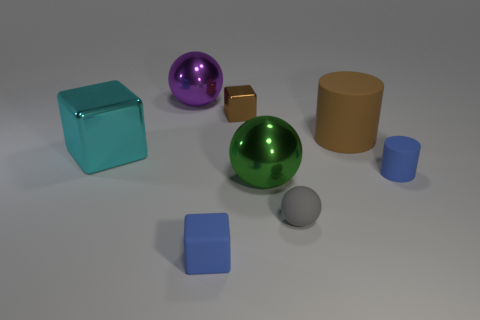Add 1 cyan blocks. How many objects exist? 9 Subtract all cylinders. How many objects are left? 6 Add 6 purple things. How many purple things are left? 7 Add 1 matte blocks. How many matte blocks exist? 2 Subtract 0 red cubes. How many objects are left? 8 Subtract all big cyan metal cubes. Subtract all brown blocks. How many objects are left? 6 